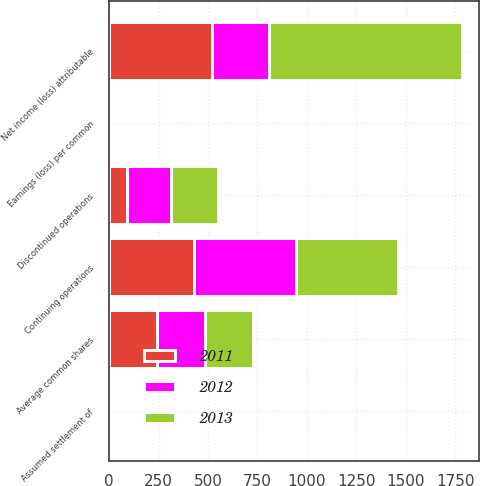Convert chart. <chart><loc_0><loc_0><loc_500><loc_500><stacked_bar_chart><ecel><fcel>Continuing operations<fcel>Discontinued operations<fcel>Net income (loss) attributable<fcel>Average common shares<fcel>Assumed settlement of<fcel>Earnings (loss) per common<nl><fcel>2012<fcel>512<fcel>223<fcel>289<fcel>244.5<fcel>1.9<fcel>1.18<nl><fcel>2013<fcel>516<fcel>241.5<fcel>974<fcel>243<fcel>0.4<fcel>4.01<nl><fcel>2011<fcel>431<fcel>88<fcel>519<fcel>242.1<fcel>0.6<fcel>2.15<nl></chart> 